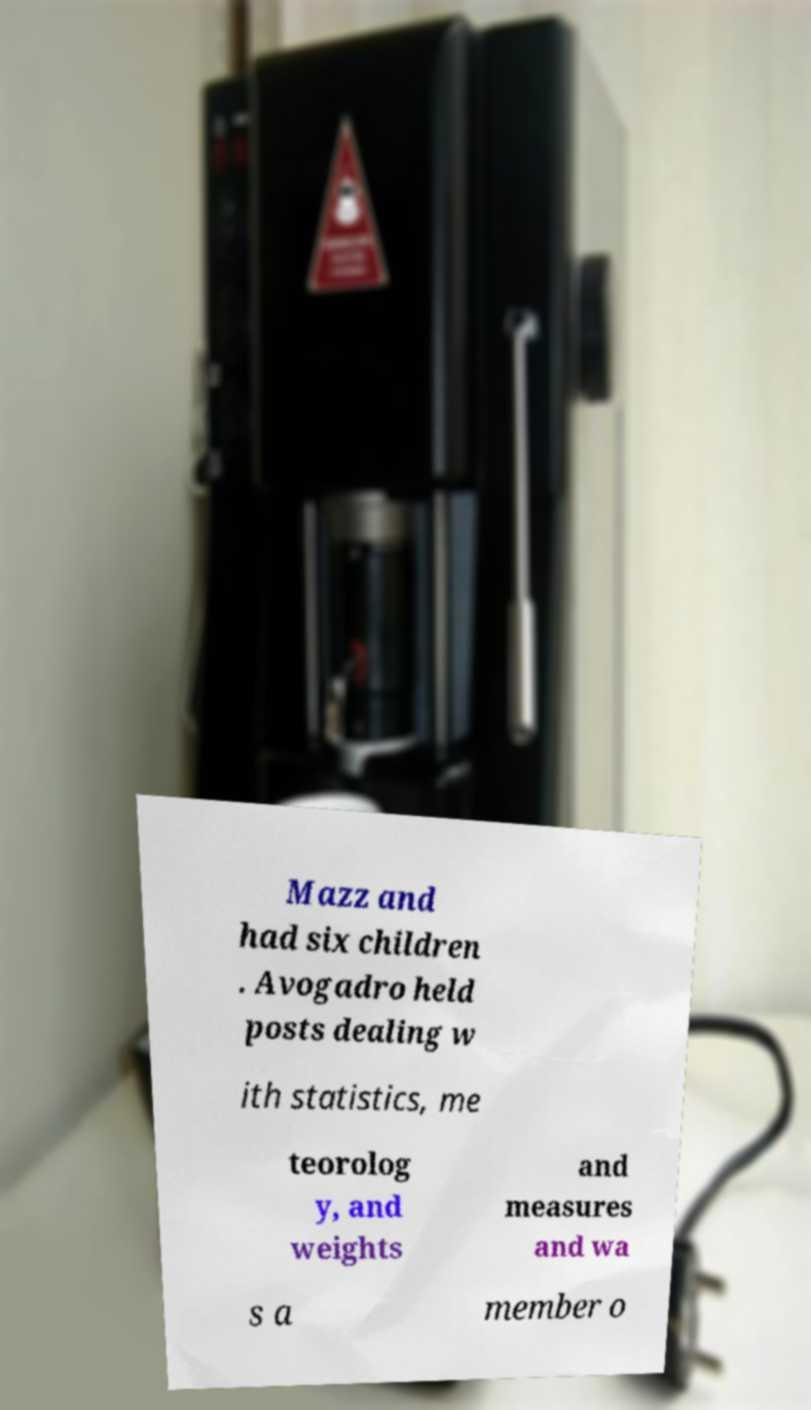Can you read and provide the text displayed in the image?This photo seems to have some interesting text. Can you extract and type it out for me? Mazz and had six children . Avogadro held posts dealing w ith statistics, me teorolog y, and weights and measures and wa s a member o 